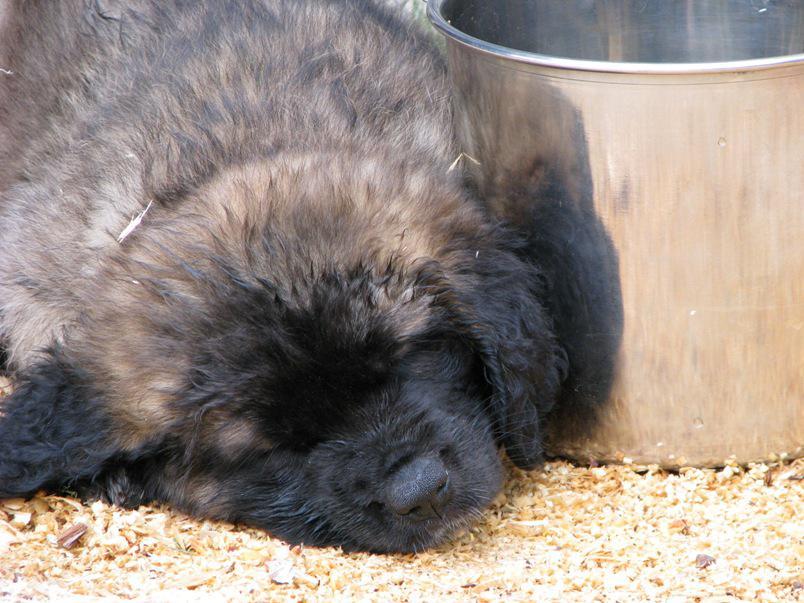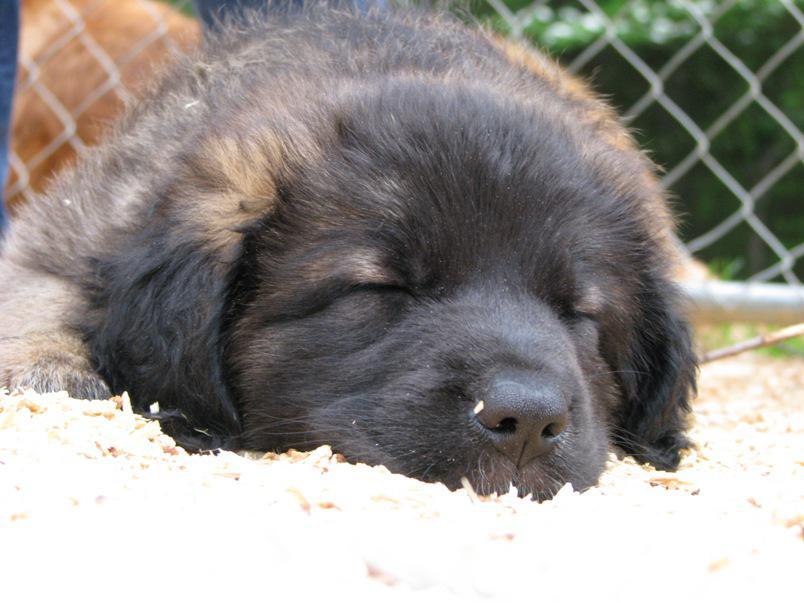The first image is the image on the left, the second image is the image on the right. Analyze the images presented: Is the assertion "In one of the images there are at least three large dogs laying on the ground next to each other." valid? Answer yes or no. No. The first image is the image on the left, the second image is the image on the right. Analyze the images presented: Is the assertion "An image shows more than one dog lying in a sleeping pose." valid? Answer yes or no. No. 